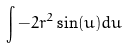Convert formula to latex. <formula><loc_0><loc_0><loc_500><loc_500>\int - 2 r ^ { 2 } \sin ( u ) d u</formula> 